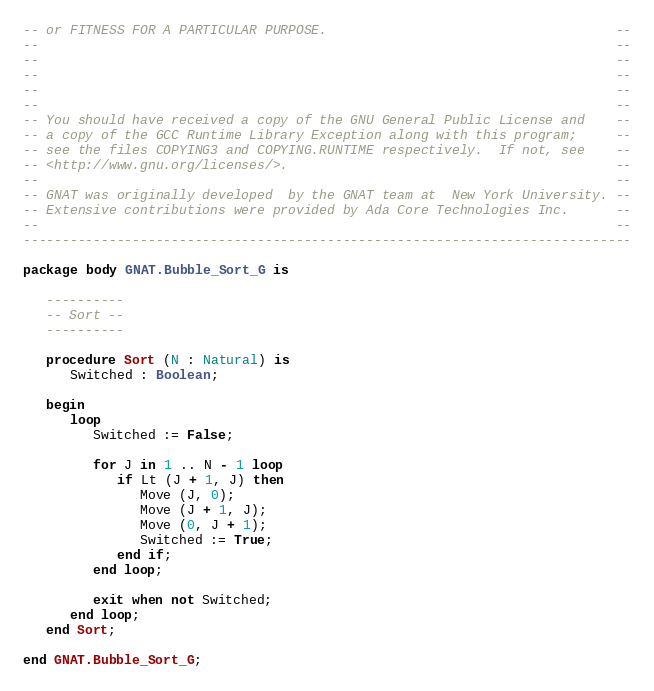<code> <loc_0><loc_0><loc_500><loc_500><_Ada_>-- or FITNESS FOR A PARTICULAR PURPOSE.                                     --
--                                                                          --
--                                                                          --
--                                                                          --
--                                                                          --
--                                                                          --
-- You should have received a copy of the GNU General Public License and    --
-- a copy of the GCC Runtime Library Exception along with this program;     --
-- see the files COPYING3 and COPYING.RUNTIME respectively.  If not, see    --
-- <http://www.gnu.org/licenses/>.                                          --
--                                                                          --
-- GNAT was originally developed  by the GNAT team at  New York University. --
-- Extensive contributions were provided by Ada Core Technologies Inc.      --
--                                                                          --
------------------------------------------------------------------------------

package body GNAT.Bubble_Sort_G is

   ----------
   -- Sort --
   ----------

   procedure Sort (N : Natural) is
      Switched : Boolean;

   begin
      loop
         Switched := False;

         for J in 1 .. N - 1 loop
            if Lt (J + 1, J) then
               Move (J, 0);
               Move (J + 1, J);
               Move (0, J + 1);
               Switched := True;
            end if;
         end loop;

         exit when not Switched;
      end loop;
   end Sort;

end GNAT.Bubble_Sort_G;
</code> 